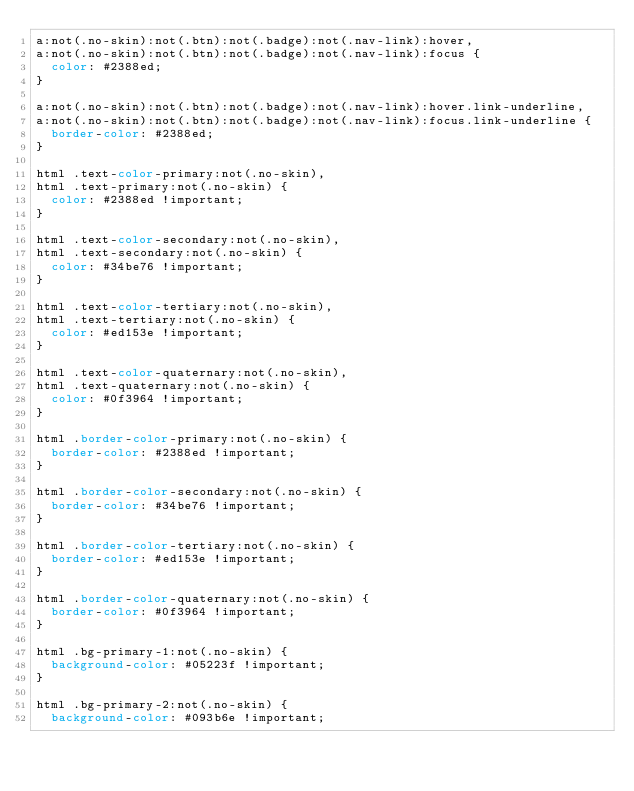<code> <loc_0><loc_0><loc_500><loc_500><_CSS_>a:not(.no-skin):not(.btn):not(.badge):not(.nav-link):hover,
a:not(.no-skin):not(.btn):not(.badge):not(.nav-link):focus {
	color: #2388ed;
}

a:not(.no-skin):not(.btn):not(.badge):not(.nav-link):hover.link-underline,
a:not(.no-skin):not(.btn):not(.badge):not(.nav-link):focus.link-underline {
	border-color: #2388ed;
}

html .text-color-primary:not(.no-skin),
html .text-primary:not(.no-skin) {
	color: #2388ed !important;
}

html .text-color-secondary:not(.no-skin),
html .text-secondary:not(.no-skin) {
	color: #34be76 !important;
}

html .text-color-tertiary:not(.no-skin),
html .text-tertiary:not(.no-skin) {
	color: #ed153e !important;
}

html .text-color-quaternary:not(.no-skin),
html .text-quaternary:not(.no-skin) {
	color: #0f3964 !important;
}

html .border-color-primary:not(.no-skin) {
	border-color: #2388ed !important;
}

html .border-color-secondary:not(.no-skin) {
	border-color: #34be76 !important;
}

html .border-color-tertiary:not(.no-skin) {
	border-color: #ed153e !important;
}

html .border-color-quaternary:not(.no-skin) {
	border-color: #0f3964 !important;
}

html .bg-primary-1:not(.no-skin) {
	background-color: #05223f !important;
}

html .bg-primary-2:not(.no-skin) {
	background-color: #093b6e !important;</code> 